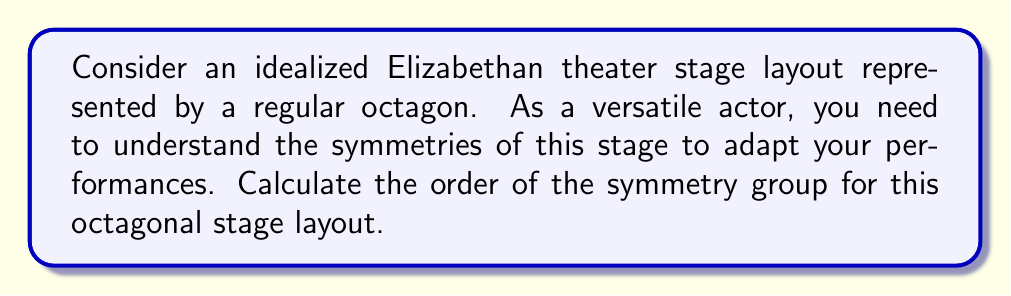What is the answer to this math problem? Let's approach this step-by-step:

1) The symmetry group of a regular octagon is the dihedral group $D_8$.

2) The order of the dihedral group $D_n$ is given by the formula:

   $$|D_n| = 2n$$

   where $n$ is the number of sides of the regular polygon.

3) In this case, $n = 8$ (octagon), so we have:

   $$|D_8| = 2 \cdot 8 = 16$$

4) To understand these 16 symmetries:
   - There are 8 rotational symmetries (including the identity rotation):
     Rotations by $0°, 45°, 90°, 135°, 180°, 225°, 270°, 315°$
   - There are 8 reflection symmetries:
     4 reflections across diagonals and 4 reflections across lines connecting midpoints of opposite sides

5) As an actor, you could use this knowledge to ensure your performance is equally impactful from all viewing angles, utilizing the stage's inherent symmetry.

[asy]
unitsize(2cm);
for(int i=0; i<8; ++i) {
  draw(rotate(45*i)*(1,0)--(cos(pi/8),sin(pi/8)), blue);
}
draw((-1,0)--(1,0), red, dashed);
draw((0,-1)--(0,1), red, dashed);
draw((-cos(pi/4),-cos(pi/4))--(cos(pi/4),cos(pi/4)), red, dashed);
draw((-cos(pi/4),cos(pi/4))--(cos(pi/4),-cos(pi/4)), red, dashed);
[/asy]
Answer: 16 